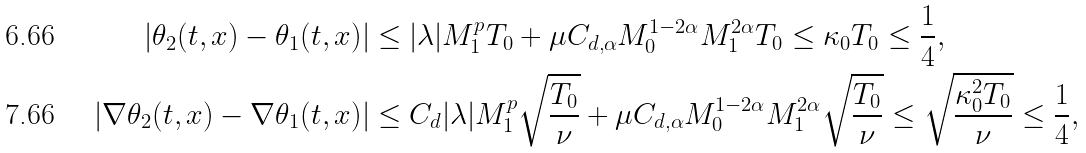Convert formula to latex. <formula><loc_0><loc_0><loc_500><loc_500>| \theta _ { 2 } ( t , x ) - \theta _ { 1 } ( t , x ) | & \leq | \lambda | M _ { 1 } ^ { p } T _ { 0 } + \mu C _ { d , \alpha } M _ { 0 } ^ { 1 - 2 \alpha } M _ { 1 } ^ { 2 \alpha } T _ { 0 } \leq \kappa _ { 0 } T _ { 0 } \leq \frac { 1 } { 4 } , \\ | \nabla \theta _ { 2 } ( t , x ) - \nabla \theta _ { 1 } ( t , x ) | & \leq C _ { d } | \lambda | M _ { 1 } ^ { p } \sqrt { \frac { T _ { 0 } } { \nu } } + \mu C _ { d , \alpha } M _ { 0 } ^ { 1 - 2 \alpha } M _ { 1 } ^ { 2 \alpha } \sqrt { \frac { T _ { 0 } } { \nu } } \leq \sqrt { \frac { \kappa _ { 0 } ^ { 2 } T _ { 0 } } { \nu } } \leq \frac { 1 } { 4 } ,</formula> 